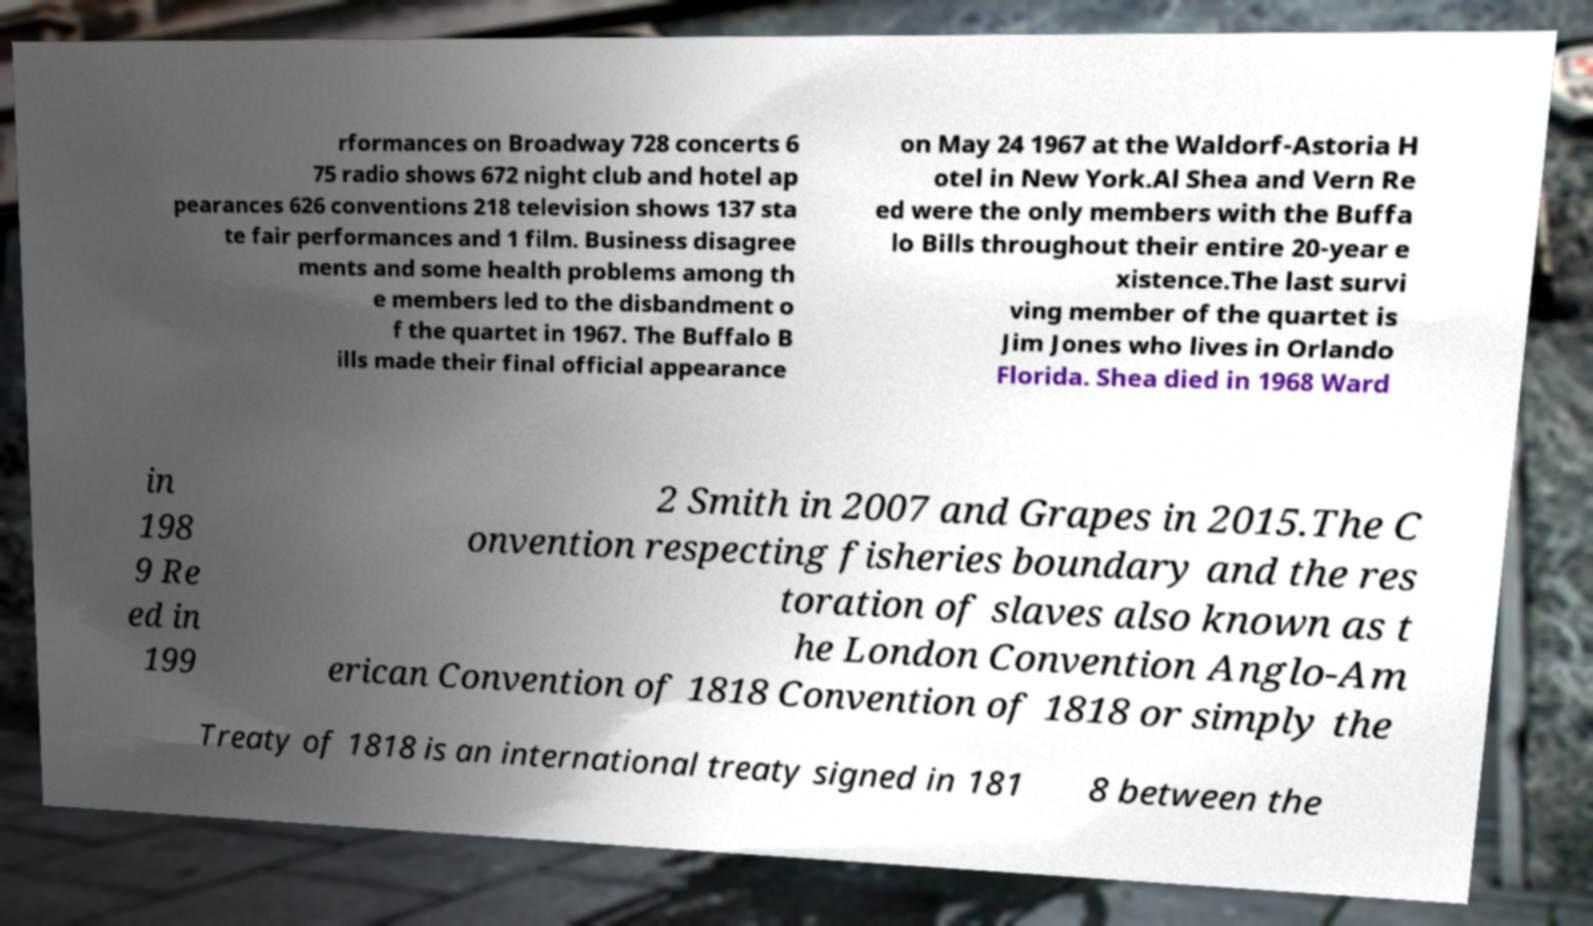Can you accurately transcribe the text from the provided image for me? rformances on Broadway 728 concerts 6 75 radio shows 672 night club and hotel ap pearances 626 conventions 218 television shows 137 sta te fair performances and 1 film. Business disagree ments and some health problems among th e members led to the disbandment o f the quartet in 1967. The Buffalo B ills made their final official appearance on May 24 1967 at the Waldorf-Astoria H otel in New York.Al Shea and Vern Re ed were the only members with the Buffa lo Bills throughout their entire 20-year e xistence.The last survi ving member of the quartet is Jim Jones who lives in Orlando Florida. Shea died in 1968 Ward in 198 9 Re ed in 199 2 Smith in 2007 and Grapes in 2015.The C onvention respecting fisheries boundary and the res toration of slaves also known as t he London Convention Anglo-Am erican Convention of 1818 Convention of 1818 or simply the Treaty of 1818 is an international treaty signed in 181 8 between the 